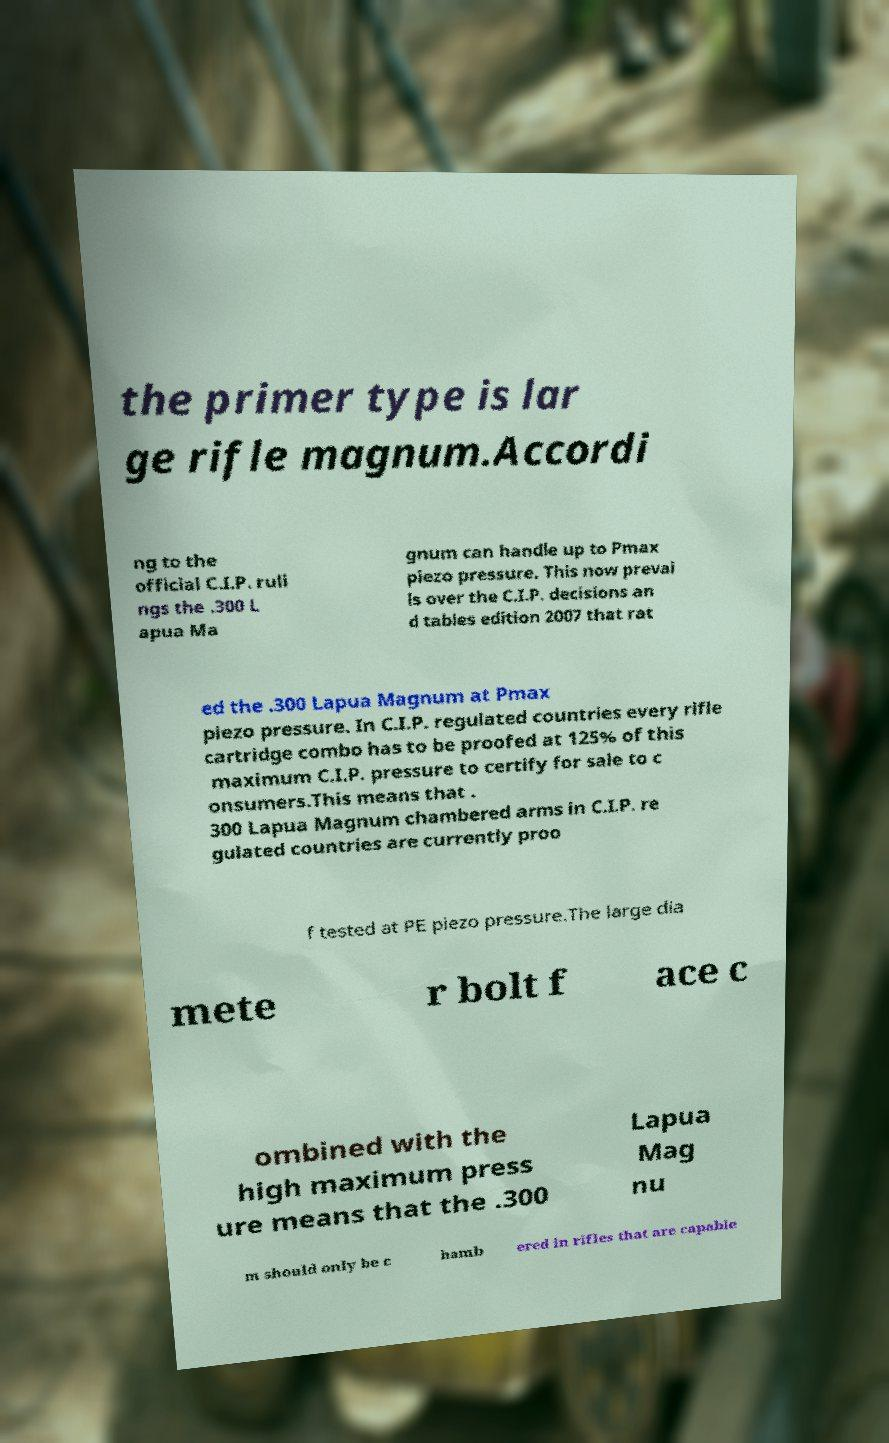What messages or text are displayed in this image? I need them in a readable, typed format. the primer type is lar ge rifle magnum.Accordi ng to the official C.I.P. ruli ngs the .300 L apua Ma gnum can handle up to Pmax piezo pressure. This now prevai ls over the C.I.P. decisions an d tables edition 2007 that rat ed the .300 Lapua Magnum at Pmax piezo pressure. In C.I.P. regulated countries every rifle cartridge combo has to be proofed at 125% of this maximum C.I.P. pressure to certify for sale to c onsumers.This means that . 300 Lapua Magnum chambered arms in C.I.P. re gulated countries are currently proo f tested at PE piezo pressure.The large dia mete r bolt f ace c ombined with the high maximum press ure means that the .300 Lapua Mag nu m should only be c hamb ered in rifles that are capable 